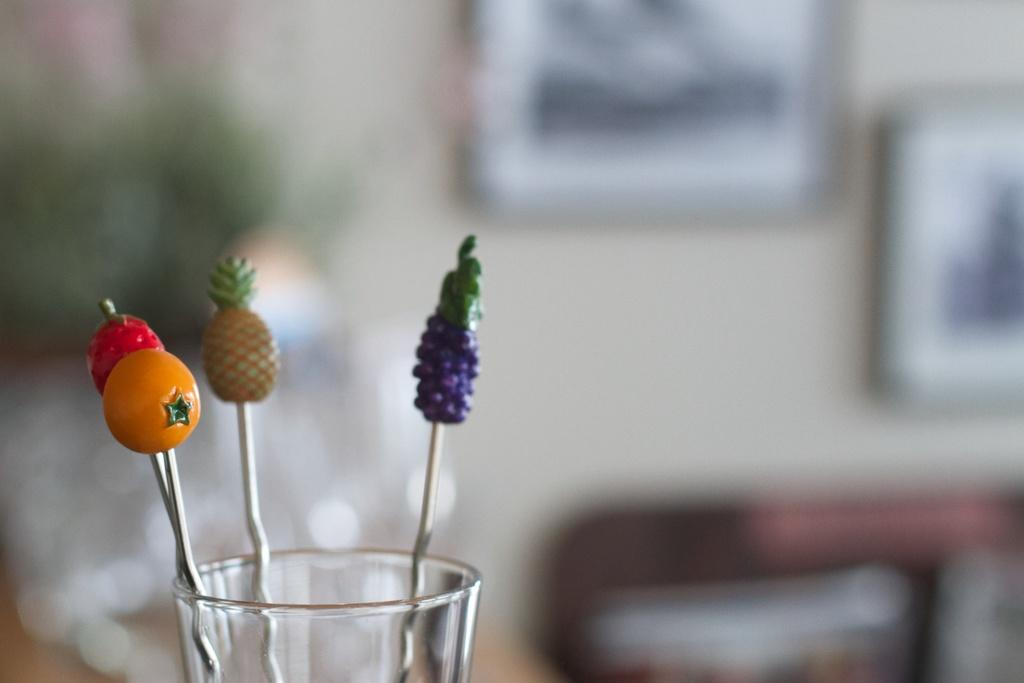What is present in the image that can hold liquid? There is a glass in the image. What can be found inside the glass? There are objects in the glass. What type of structure is visible in the image? There is a wall in the image. What decorative items are on the wall? There are photo frames on the wall. What type of chess pieces can be seen on the canvas in the image? There is no chess or canvas present in the image. What type of battle is depicted in the image? There is no battle depicted in the image. 